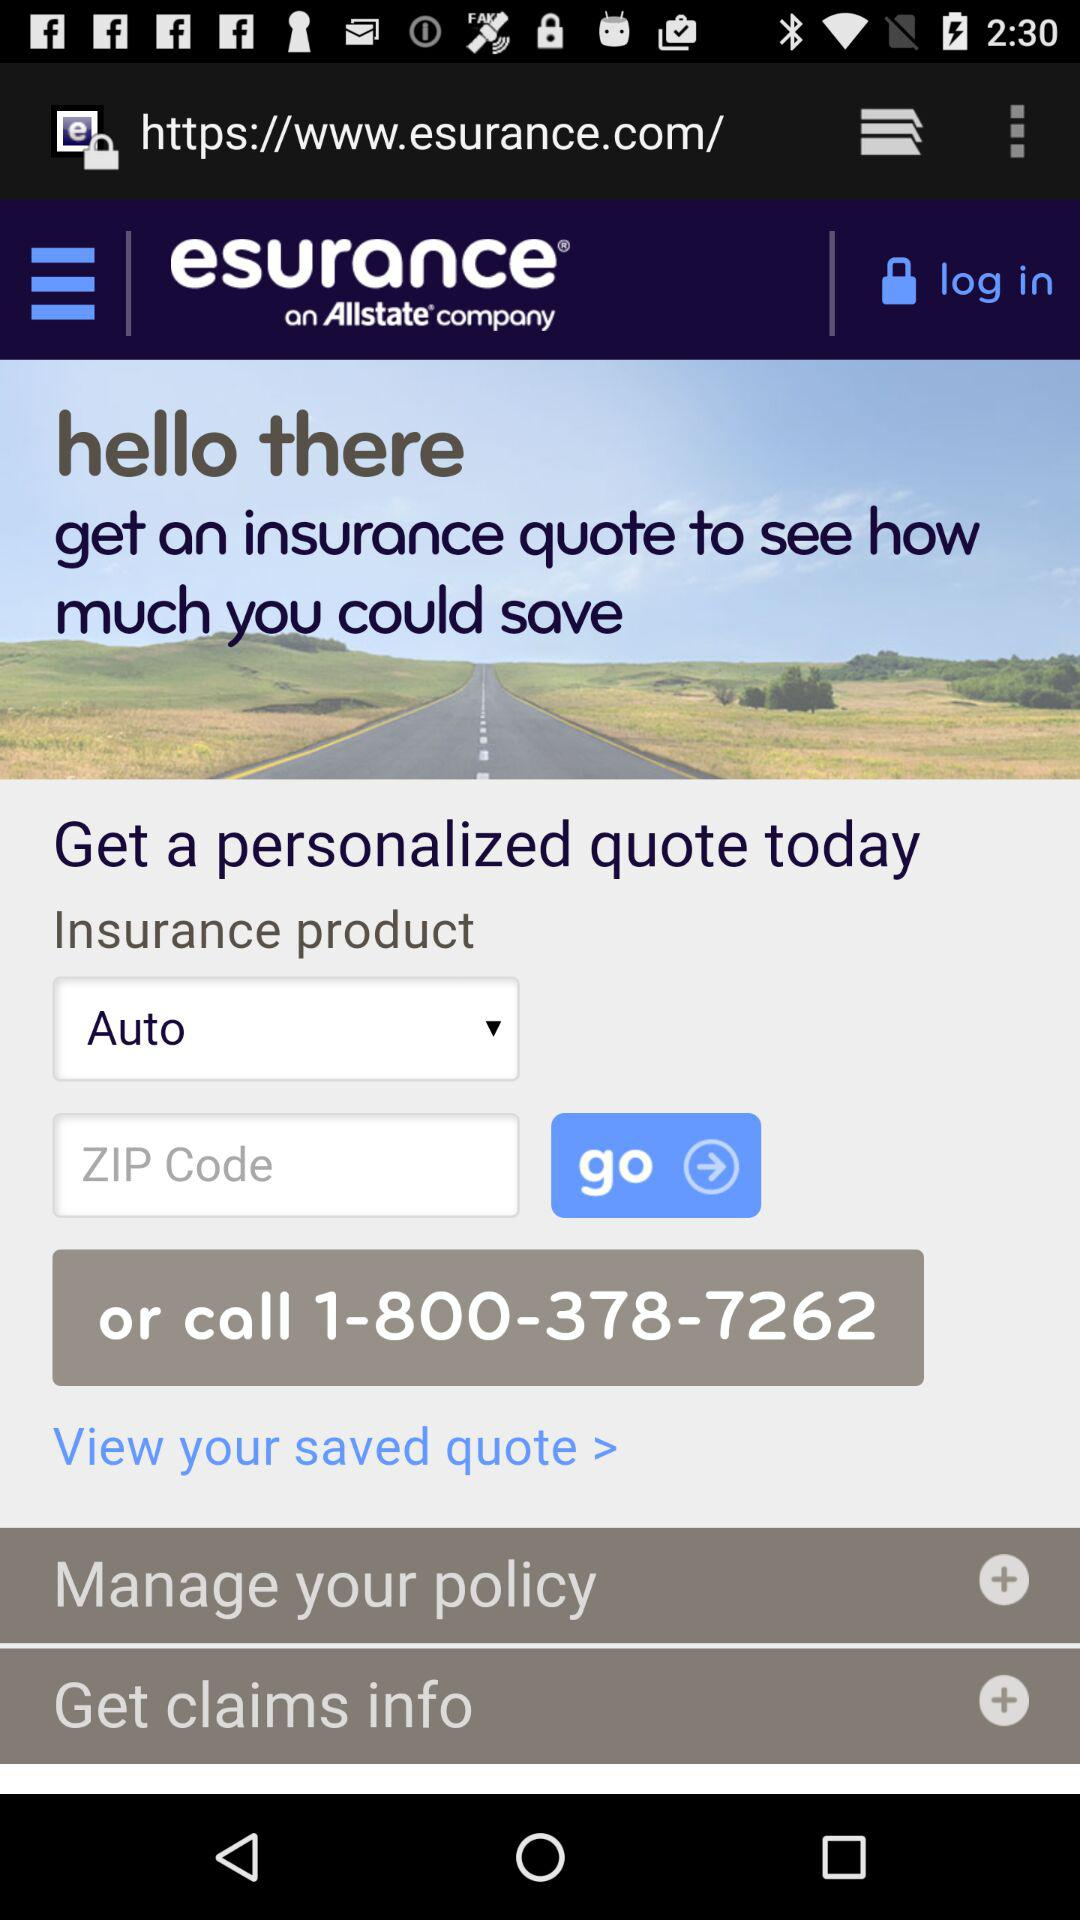Which type of insurance product is selected? The selected type of insurance product is "Auto". 